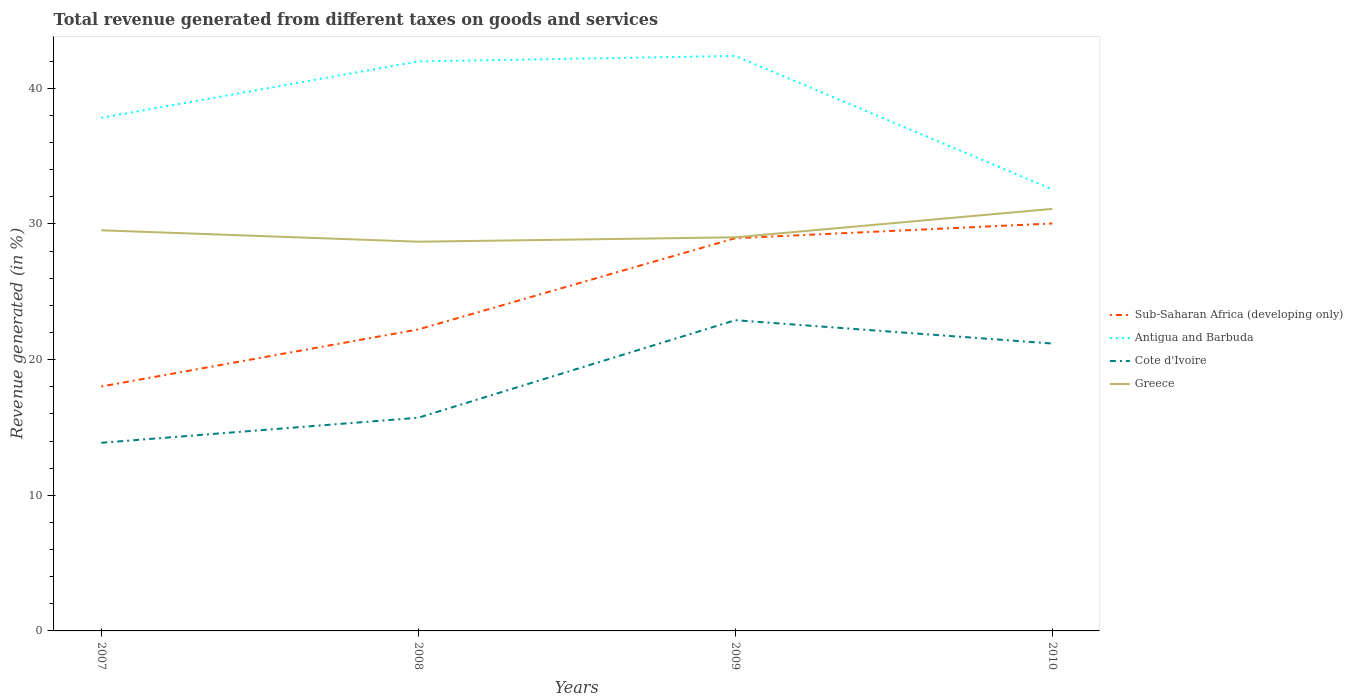Is the number of lines equal to the number of legend labels?
Keep it short and to the point. Yes. Across all years, what is the maximum total revenue generated in Antigua and Barbuda?
Your answer should be very brief. 32.55. What is the total total revenue generated in Sub-Saharan Africa (developing only) in the graph?
Keep it short and to the point. -12.02. What is the difference between the highest and the second highest total revenue generated in Cote d'Ivoire?
Offer a terse response. 9.04. What is the difference between the highest and the lowest total revenue generated in Greece?
Provide a short and direct response. 1. Is the total revenue generated in Antigua and Barbuda strictly greater than the total revenue generated in Sub-Saharan Africa (developing only) over the years?
Make the answer very short. No. How many lines are there?
Ensure brevity in your answer.  4. How many years are there in the graph?
Make the answer very short. 4. What is the difference between two consecutive major ticks on the Y-axis?
Your response must be concise. 10. Are the values on the major ticks of Y-axis written in scientific E-notation?
Provide a short and direct response. No. What is the title of the graph?
Your answer should be very brief. Total revenue generated from different taxes on goods and services. What is the label or title of the X-axis?
Provide a short and direct response. Years. What is the label or title of the Y-axis?
Ensure brevity in your answer.  Revenue generated (in %). What is the Revenue generated (in %) of Sub-Saharan Africa (developing only) in 2007?
Offer a very short reply. 18.02. What is the Revenue generated (in %) in Antigua and Barbuda in 2007?
Ensure brevity in your answer.  37.83. What is the Revenue generated (in %) of Cote d'Ivoire in 2007?
Your response must be concise. 13.87. What is the Revenue generated (in %) of Greece in 2007?
Make the answer very short. 29.53. What is the Revenue generated (in %) in Sub-Saharan Africa (developing only) in 2008?
Your answer should be compact. 22.23. What is the Revenue generated (in %) of Antigua and Barbuda in 2008?
Offer a terse response. 41.98. What is the Revenue generated (in %) of Cote d'Ivoire in 2008?
Give a very brief answer. 15.72. What is the Revenue generated (in %) of Greece in 2008?
Provide a succinct answer. 28.69. What is the Revenue generated (in %) of Sub-Saharan Africa (developing only) in 2009?
Your response must be concise. 28.95. What is the Revenue generated (in %) of Antigua and Barbuda in 2009?
Offer a very short reply. 42.39. What is the Revenue generated (in %) of Cote d'Ivoire in 2009?
Offer a very short reply. 22.91. What is the Revenue generated (in %) of Greece in 2009?
Provide a succinct answer. 29.02. What is the Revenue generated (in %) of Sub-Saharan Africa (developing only) in 2010?
Your answer should be very brief. 30.04. What is the Revenue generated (in %) in Antigua and Barbuda in 2010?
Your answer should be compact. 32.55. What is the Revenue generated (in %) of Cote d'Ivoire in 2010?
Provide a succinct answer. 21.19. What is the Revenue generated (in %) in Greece in 2010?
Your response must be concise. 31.11. Across all years, what is the maximum Revenue generated (in %) in Sub-Saharan Africa (developing only)?
Make the answer very short. 30.04. Across all years, what is the maximum Revenue generated (in %) in Antigua and Barbuda?
Provide a succinct answer. 42.39. Across all years, what is the maximum Revenue generated (in %) in Cote d'Ivoire?
Your answer should be compact. 22.91. Across all years, what is the maximum Revenue generated (in %) in Greece?
Make the answer very short. 31.11. Across all years, what is the minimum Revenue generated (in %) of Sub-Saharan Africa (developing only)?
Offer a terse response. 18.02. Across all years, what is the minimum Revenue generated (in %) of Antigua and Barbuda?
Ensure brevity in your answer.  32.55. Across all years, what is the minimum Revenue generated (in %) in Cote d'Ivoire?
Ensure brevity in your answer.  13.87. Across all years, what is the minimum Revenue generated (in %) of Greece?
Your answer should be compact. 28.69. What is the total Revenue generated (in %) in Sub-Saharan Africa (developing only) in the graph?
Offer a terse response. 99.24. What is the total Revenue generated (in %) of Antigua and Barbuda in the graph?
Give a very brief answer. 154.75. What is the total Revenue generated (in %) in Cote d'Ivoire in the graph?
Give a very brief answer. 73.68. What is the total Revenue generated (in %) of Greece in the graph?
Provide a succinct answer. 118.36. What is the difference between the Revenue generated (in %) of Sub-Saharan Africa (developing only) in 2007 and that in 2008?
Ensure brevity in your answer.  -4.21. What is the difference between the Revenue generated (in %) of Antigua and Barbuda in 2007 and that in 2008?
Your response must be concise. -4.16. What is the difference between the Revenue generated (in %) of Cote d'Ivoire in 2007 and that in 2008?
Offer a terse response. -1.85. What is the difference between the Revenue generated (in %) of Greece in 2007 and that in 2008?
Offer a very short reply. 0.84. What is the difference between the Revenue generated (in %) in Sub-Saharan Africa (developing only) in 2007 and that in 2009?
Ensure brevity in your answer.  -10.93. What is the difference between the Revenue generated (in %) in Antigua and Barbuda in 2007 and that in 2009?
Make the answer very short. -4.56. What is the difference between the Revenue generated (in %) of Cote d'Ivoire in 2007 and that in 2009?
Your answer should be very brief. -9.04. What is the difference between the Revenue generated (in %) in Greece in 2007 and that in 2009?
Offer a terse response. 0.52. What is the difference between the Revenue generated (in %) in Sub-Saharan Africa (developing only) in 2007 and that in 2010?
Your answer should be very brief. -12.02. What is the difference between the Revenue generated (in %) in Antigua and Barbuda in 2007 and that in 2010?
Ensure brevity in your answer.  5.28. What is the difference between the Revenue generated (in %) of Cote d'Ivoire in 2007 and that in 2010?
Keep it short and to the point. -7.32. What is the difference between the Revenue generated (in %) of Greece in 2007 and that in 2010?
Your answer should be very brief. -1.58. What is the difference between the Revenue generated (in %) of Sub-Saharan Africa (developing only) in 2008 and that in 2009?
Offer a terse response. -6.72. What is the difference between the Revenue generated (in %) in Antigua and Barbuda in 2008 and that in 2009?
Offer a terse response. -0.41. What is the difference between the Revenue generated (in %) in Cote d'Ivoire in 2008 and that in 2009?
Offer a very short reply. -7.19. What is the difference between the Revenue generated (in %) in Greece in 2008 and that in 2009?
Your answer should be very brief. -0.32. What is the difference between the Revenue generated (in %) in Sub-Saharan Africa (developing only) in 2008 and that in 2010?
Provide a short and direct response. -7.81. What is the difference between the Revenue generated (in %) of Antigua and Barbuda in 2008 and that in 2010?
Your answer should be very brief. 9.44. What is the difference between the Revenue generated (in %) of Cote d'Ivoire in 2008 and that in 2010?
Offer a terse response. -5.47. What is the difference between the Revenue generated (in %) in Greece in 2008 and that in 2010?
Make the answer very short. -2.42. What is the difference between the Revenue generated (in %) of Sub-Saharan Africa (developing only) in 2009 and that in 2010?
Offer a terse response. -1.09. What is the difference between the Revenue generated (in %) of Antigua and Barbuda in 2009 and that in 2010?
Offer a terse response. 9.84. What is the difference between the Revenue generated (in %) of Cote d'Ivoire in 2009 and that in 2010?
Offer a very short reply. 1.72. What is the difference between the Revenue generated (in %) of Greece in 2009 and that in 2010?
Provide a succinct answer. -2.1. What is the difference between the Revenue generated (in %) in Sub-Saharan Africa (developing only) in 2007 and the Revenue generated (in %) in Antigua and Barbuda in 2008?
Make the answer very short. -23.96. What is the difference between the Revenue generated (in %) of Sub-Saharan Africa (developing only) in 2007 and the Revenue generated (in %) of Cote d'Ivoire in 2008?
Provide a short and direct response. 2.3. What is the difference between the Revenue generated (in %) in Sub-Saharan Africa (developing only) in 2007 and the Revenue generated (in %) in Greece in 2008?
Provide a succinct answer. -10.67. What is the difference between the Revenue generated (in %) in Antigua and Barbuda in 2007 and the Revenue generated (in %) in Cote d'Ivoire in 2008?
Your answer should be very brief. 22.11. What is the difference between the Revenue generated (in %) of Antigua and Barbuda in 2007 and the Revenue generated (in %) of Greece in 2008?
Make the answer very short. 9.13. What is the difference between the Revenue generated (in %) in Cote d'Ivoire in 2007 and the Revenue generated (in %) in Greece in 2008?
Your answer should be very brief. -14.82. What is the difference between the Revenue generated (in %) of Sub-Saharan Africa (developing only) in 2007 and the Revenue generated (in %) of Antigua and Barbuda in 2009?
Make the answer very short. -24.37. What is the difference between the Revenue generated (in %) in Sub-Saharan Africa (developing only) in 2007 and the Revenue generated (in %) in Cote d'Ivoire in 2009?
Your answer should be compact. -4.89. What is the difference between the Revenue generated (in %) in Sub-Saharan Africa (developing only) in 2007 and the Revenue generated (in %) in Greece in 2009?
Your answer should be very brief. -11. What is the difference between the Revenue generated (in %) of Antigua and Barbuda in 2007 and the Revenue generated (in %) of Cote d'Ivoire in 2009?
Give a very brief answer. 14.92. What is the difference between the Revenue generated (in %) in Antigua and Barbuda in 2007 and the Revenue generated (in %) in Greece in 2009?
Offer a very short reply. 8.81. What is the difference between the Revenue generated (in %) of Cote d'Ivoire in 2007 and the Revenue generated (in %) of Greece in 2009?
Make the answer very short. -15.15. What is the difference between the Revenue generated (in %) in Sub-Saharan Africa (developing only) in 2007 and the Revenue generated (in %) in Antigua and Barbuda in 2010?
Give a very brief answer. -14.53. What is the difference between the Revenue generated (in %) of Sub-Saharan Africa (developing only) in 2007 and the Revenue generated (in %) of Cote d'Ivoire in 2010?
Your response must be concise. -3.17. What is the difference between the Revenue generated (in %) of Sub-Saharan Africa (developing only) in 2007 and the Revenue generated (in %) of Greece in 2010?
Your answer should be compact. -13.09. What is the difference between the Revenue generated (in %) in Antigua and Barbuda in 2007 and the Revenue generated (in %) in Cote d'Ivoire in 2010?
Provide a short and direct response. 16.64. What is the difference between the Revenue generated (in %) in Antigua and Barbuda in 2007 and the Revenue generated (in %) in Greece in 2010?
Provide a short and direct response. 6.71. What is the difference between the Revenue generated (in %) in Cote d'Ivoire in 2007 and the Revenue generated (in %) in Greece in 2010?
Keep it short and to the point. -17.24. What is the difference between the Revenue generated (in %) in Sub-Saharan Africa (developing only) in 2008 and the Revenue generated (in %) in Antigua and Barbuda in 2009?
Your answer should be compact. -20.16. What is the difference between the Revenue generated (in %) in Sub-Saharan Africa (developing only) in 2008 and the Revenue generated (in %) in Cote d'Ivoire in 2009?
Your answer should be very brief. -0.68. What is the difference between the Revenue generated (in %) in Sub-Saharan Africa (developing only) in 2008 and the Revenue generated (in %) in Greece in 2009?
Your response must be concise. -6.79. What is the difference between the Revenue generated (in %) of Antigua and Barbuda in 2008 and the Revenue generated (in %) of Cote d'Ivoire in 2009?
Give a very brief answer. 19.08. What is the difference between the Revenue generated (in %) in Antigua and Barbuda in 2008 and the Revenue generated (in %) in Greece in 2009?
Offer a terse response. 12.97. What is the difference between the Revenue generated (in %) of Sub-Saharan Africa (developing only) in 2008 and the Revenue generated (in %) of Antigua and Barbuda in 2010?
Provide a succinct answer. -10.32. What is the difference between the Revenue generated (in %) of Sub-Saharan Africa (developing only) in 2008 and the Revenue generated (in %) of Cote d'Ivoire in 2010?
Offer a terse response. 1.04. What is the difference between the Revenue generated (in %) in Sub-Saharan Africa (developing only) in 2008 and the Revenue generated (in %) in Greece in 2010?
Ensure brevity in your answer.  -8.89. What is the difference between the Revenue generated (in %) of Antigua and Barbuda in 2008 and the Revenue generated (in %) of Cote d'Ivoire in 2010?
Provide a succinct answer. 20.8. What is the difference between the Revenue generated (in %) in Antigua and Barbuda in 2008 and the Revenue generated (in %) in Greece in 2010?
Offer a terse response. 10.87. What is the difference between the Revenue generated (in %) of Cote d'Ivoire in 2008 and the Revenue generated (in %) of Greece in 2010?
Your answer should be compact. -15.4. What is the difference between the Revenue generated (in %) of Sub-Saharan Africa (developing only) in 2009 and the Revenue generated (in %) of Antigua and Barbuda in 2010?
Provide a short and direct response. -3.6. What is the difference between the Revenue generated (in %) in Sub-Saharan Africa (developing only) in 2009 and the Revenue generated (in %) in Cote d'Ivoire in 2010?
Keep it short and to the point. 7.76. What is the difference between the Revenue generated (in %) in Sub-Saharan Africa (developing only) in 2009 and the Revenue generated (in %) in Greece in 2010?
Offer a very short reply. -2.16. What is the difference between the Revenue generated (in %) of Antigua and Barbuda in 2009 and the Revenue generated (in %) of Cote d'Ivoire in 2010?
Ensure brevity in your answer.  21.2. What is the difference between the Revenue generated (in %) of Antigua and Barbuda in 2009 and the Revenue generated (in %) of Greece in 2010?
Provide a short and direct response. 11.28. What is the difference between the Revenue generated (in %) in Cote d'Ivoire in 2009 and the Revenue generated (in %) in Greece in 2010?
Provide a succinct answer. -8.21. What is the average Revenue generated (in %) in Sub-Saharan Africa (developing only) per year?
Offer a very short reply. 24.81. What is the average Revenue generated (in %) in Antigua and Barbuda per year?
Provide a short and direct response. 38.69. What is the average Revenue generated (in %) of Cote d'Ivoire per year?
Make the answer very short. 18.42. What is the average Revenue generated (in %) of Greece per year?
Make the answer very short. 29.59. In the year 2007, what is the difference between the Revenue generated (in %) in Sub-Saharan Africa (developing only) and Revenue generated (in %) in Antigua and Barbuda?
Your answer should be compact. -19.81. In the year 2007, what is the difference between the Revenue generated (in %) of Sub-Saharan Africa (developing only) and Revenue generated (in %) of Cote d'Ivoire?
Provide a short and direct response. 4.15. In the year 2007, what is the difference between the Revenue generated (in %) in Sub-Saharan Africa (developing only) and Revenue generated (in %) in Greece?
Provide a succinct answer. -11.51. In the year 2007, what is the difference between the Revenue generated (in %) of Antigua and Barbuda and Revenue generated (in %) of Cote d'Ivoire?
Your answer should be very brief. 23.96. In the year 2007, what is the difference between the Revenue generated (in %) of Antigua and Barbuda and Revenue generated (in %) of Greece?
Your response must be concise. 8.29. In the year 2007, what is the difference between the Revenue generated (in %) in Cote d'Ivoire and Revenue generated (in %) in Greece?
Keep it short and to the point. -15.67. In the year 2008, what is the difference between the Revenue generated (in %) of Sub-Saharan Africa (developing only) and Revenue generated (in %) of Antigua and Barbuda?
Give a very brief answer. -19.76. In the year 2008, what is the difference between the Revenue generated (in %) in Sub-Saharan Africa (developing only) and Revenue generated (in %) in Cote d'Ivoire?
Your answer should be very brief. 6.51. In the year 2008, what is the difference between the Revenue generated (in %) of Sub-Saharan Africa (developing only) and Revenue generated (in %) of Greece?
Your response must be concise. -6.47. In the year 2008, what is the difference between the Revenue generated (in %) in Antigua and Barbuda and Revenue generated (in %) in Cote d'Ivoire?
Your answer should be compact. 26.27. In the year 2008, what is the difference between the Revenue generated (in %) in Antigua and Barbuda and Revenue generated (in %) in Greece?
Your response must be concise. 13.29. In the year 2008, what is the difference between the Revenue generated (in %) in Cote d'Ivoire and Revenue generated (in %) in Greece?
Ensure brevity in your answer.  -12.98. In the year 2009, what is the difference between the Revenue generated (in %) in Sub-Saharan Africa (developing only) and Revenue generated (in %) in Antigua and Barbuda?
Ensure brevity in your answer.  -13.44. In the year 2009, what is the difference between the Revenue generated (in %) of Sub-Saharan Africa (developing only) and Revenue generated (in %) of Cote d'Ivoire?
Keep it short and to the point. 6.04. In the year 2009, what is the difference between the Revenue generated (in %) in Sub-Saharan Africa (developing only) and Revenue generated (in %) in Greece?
Your response must be concise. -0.07. In the year 2009, what is the difference between the Revenue generated (in %) in Antigua and Barbuda and Revenue generated (in %) in Cote d'Ivoire?
Keep it short and to the point. 19.48. In the year 2009, what is the difference between the Revenue generated (in %) in Antigua and Barbuda and Revenue generated (in %) in Greece?
Provide a short and direct response. 13.37. In the year 2009, what is the difference between the Revenue generated (in %) of Cote d'Ivoire and Revenue generated (in %) of Greece?
Provide a short and direct response. -6.11. In the year 2010, what is the difference between the Revenue generated (in %) of Sub-Saharan Africa (developing only) and Revenue generated (in %) of Antigua and Barbuda?
Offer a terse response. -2.51. In the year 2010, what is the difference between the Revenue generated (in %) in Sub-Saharan Africa (developing only) and Revenue generated (in %) in Cote d'Ivoire?
Offer a terse response. 8.85. In the year 2010, what is the difference between the Revenue generated (in %) of Sub-Saharan Africa (developing only) and Revenue generated (in %) of Greece?
Your answer should be very brief. -1.08. In the year 2010, what is the difference between the Revenue generated (in %) in Antigua and Barbuda and Revenue generated (in %) in Cote d'Ivoire?
Keep it short and to the point. 11.36. In the year 2010, what is the difference between the Revenue generated (in %) of Antigua and Barbuda and Revenue generated (in %) of Greece?
Ensure brevity in your answer.  1.44. In the year 2010, what is the difference between the Revenue generated (in %) of Cote d'Ivoire and Revenue generated (in %) of Greece?
Give a very brief answer. -9.93. What is the ratio of the Revenue generated (in %) in Sub-Saharan Africa (developing only) in 2007 to that in 2008?
Your answer should be very brief. 0.81. What is the ratio of the Revenue generated (in %) of Antigua and Barbuda in 2007 to that in 2008?
Your answer should be very brief. 0.9. What is the ratio of the Revenue generated (in %) in Cote d'Ivoire in 2007 to that in 2008?
Ensure brevity in your answer.  0.88. What is the ratio of the Revenue generated (in %) of Greece in 2007 to that in 2008?
Offer a very short reply. 1.03. What is the ratio of the Revenue generated (in %) in Sub-Saharan Africa (developing only) in 2007 to that in 2009?
Make the answer very short. 0.62. What is the ratio of the Revenue generated (in %) in Antigua and Barbuda in 2007 to that in 2009?
Ensure brevity in your answer.  0.89. What is the ratio of the Revenue generated (in %) of Cote d'Ivoire in 2007 to that in 2009?
Ensure brevity in your answer.  0.61. What is the ratio of the Revenue generated (in %) of Greece in 2007 to that in 2009?
Offer a very short reply. 1.02. What is the ratio of the Revenue generated (in %) of Sub-Saharan Africa (developing only) in 2007 to that in 2010?
Make the answer very short. 0.6. What is the ratio of the Revenue generated (in %) in Antigua and Barbuda in 2007 to that in 2010?
Ensure brevity in your answer.  1.16. What is the ratio of the Revenue generated (in %) of Cote d'Ivoire in 2007 to that in 2010?
Your response must be concise. 0.65. What is the ratio of the Revenue generated (in %) in Greece in 2007 to that in 2010?
Your response must be concise. 0.95. What is the ratio of the Revenue generated (in %) in Sub-Saharan Africa (developing only) in 2008 to that in 2009?
Offer a terse response. 0.77. What is the ratio of the Revenue generated (in %) in Antigua and Barbuda in 2008 to that in 2009?
Keep it short and to the point. 0.99. What is the ratio of the Revenue generated (in %) of Cote d'Ivoire in 2008 to that in 2009?
Your answer should be very brief. 0.69. What is the ratio of the Revenue generated (in %) in Sub-Saharan Africa (developing only) in 2008 to that in 2010?
Make the answer very short. 0.74. What is the ratio of the Revenue generated (in %) in Antigua and Barbuda in 2008 to that in 2010?
Your answer should be compact. 1.29. What is the ratio of the Revenue generated (in %) of Cote d'Ivoire in 2008 to that in 2010?
Offer a very short reply. 0.74. What is the ratio of the Revenue generated (in %) in Greece in 2008 to that in 2010?
Your response must be concise. 0.92. What is the ratio of the Revenue generated (in %) in Sub-Saharan Africa (developing only) in 2009 to that in 2010?
Provide a succinct answer. 0.96. What is the ratio of the Revenue generated (in %) of Antigua and Barbuda in 2009 to that in 2010?
Keep it short and to the point. 1.3. What is the ratio of the Revenue generated (in %) in Cote d'Ivoire in 2009 to that in 2010?
Offer a very short reply. 1.08. What is the ratio of the Revenue generated (in %) in Greece in 2009 to that in 2010?
Keep it short and to the point. 0.93. What is the difference between the highest and the second highest Revenue generated (in %) of Sub-Saharan Africa (developing only)?
Provide a short and direct response. 1.09. What is the difference between the highest and the second highest Revenue generated (in %) in Antigua and Barbuda?
Your response must be concise. 0.41. What is the difference between the highest and the second highest Revenue generated (in %) of Cote d'Ivoire?
Give a very brief answer. 1.72. What is the difference between the highest and the second highest Revenue generated (in %) in Greece?
Offer a very short reply. 1.58. What is the difference between the highest and the lowest Revenue generated (in %) in Sub-Saharan Africa (developing only)?
Make the answer very short. 12.02. What is the difference between the highest and the lowest Revenue generated (in %) of Antigua and Barbuda?
Provide a succinct answer. 9.84. What is the difference between the highest and the lowest Revenue generated (in %) of Cote d'Ivoire?
Ensure brevity in your answer.  9.04. What is the difference between the highest and the lowest Revenue generated (in %) of Greece?
Your answer should be very brief. 2.42. 